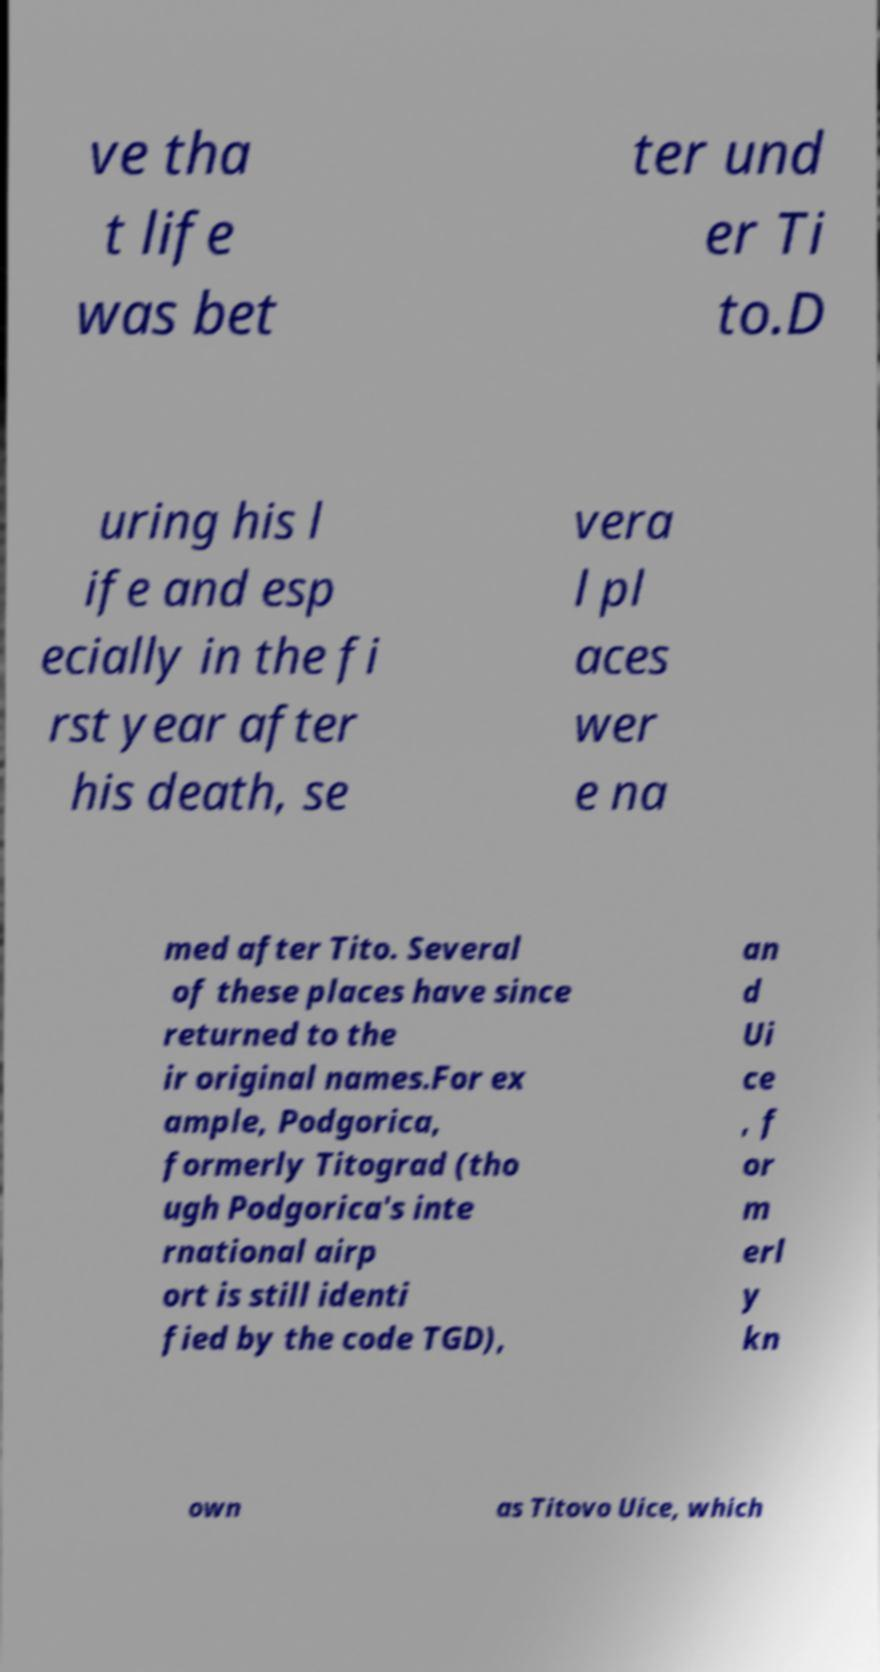What messages or text are displayed in this image? I need them in a readable, typed format. ve tha t life was bet ter und er Ti to.D uring his l ife and esp ecially in the fi rst year after his death, se vera l pl aces wer e na med after Tito. Several of these places have since returned to the ir original names.For ex ample, Podgorica, formerly Titograd (tho ugh Podgorica's inte rnational airp ort is still identi fied by the code TGD), an d Ui ce , f or m erl y kn own as Titovo Uice, which 